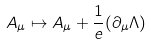Convert formula to latex. <formula><loc_0><loc_0><loc_500><loc_500>A _ { \mu } \mapsto A _ { \mu } + { \frac { 1 } { e } } ( \partial _ { \mu } \Lambda )</formula> 